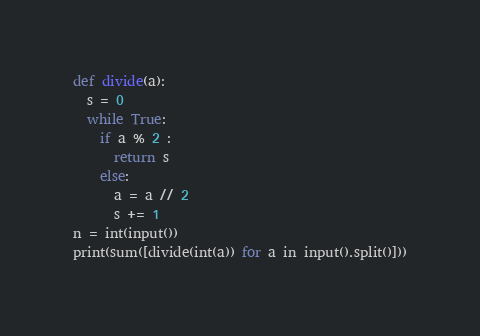Convert code to text. <code><loc_0><loc_0><loc_500><loc_500><_Python_>def divide(a):
  s = 0
  while True:
    if a % 2 :
      return s
    else:
      a = a // 2
      s += 1
n = int(input())
print(sum([divide(int(a)) for a in input().split()]))</code> 